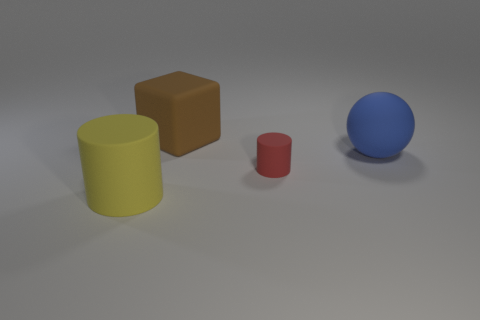Is there anything else that is the same color as the tiny rubber cylinder?
Provide a short and direct response. No. Is there a big blue metallic sphere?
Give a very brief answer. No. What number of objects are large things that are behind the large blue matte ball or large things that are behind the small matte cylinder?
Offer a very short reply. 2. Are there fewer small green matte balls than small red matte cylinders?
Provide a succinct answer. Yes. There is a small red object; are there any large rubber balls on the left side of it?
Offer a very short reply. No. Does the blue sphere have the same material as the large cylinder?
Make the answer very short. Yes. What color is the large object that is the same shape as the small red thing?
Your response must be concise. Yellow. How many yellow cylinders are made of the same material as the brown object?
Your response must be concise. 1. There is a tiny thing; how many large things are in front of it?
Keep it short and to the point. 1. How big is the sphere?
Your answer should be compact. Large. 